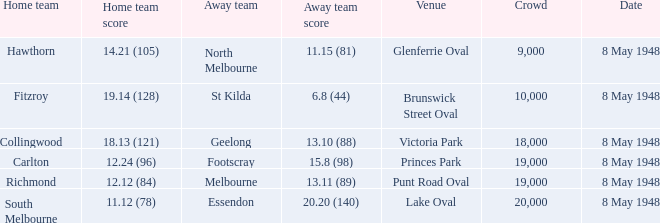Which guest team has a home score of 1 North Melbourne. 